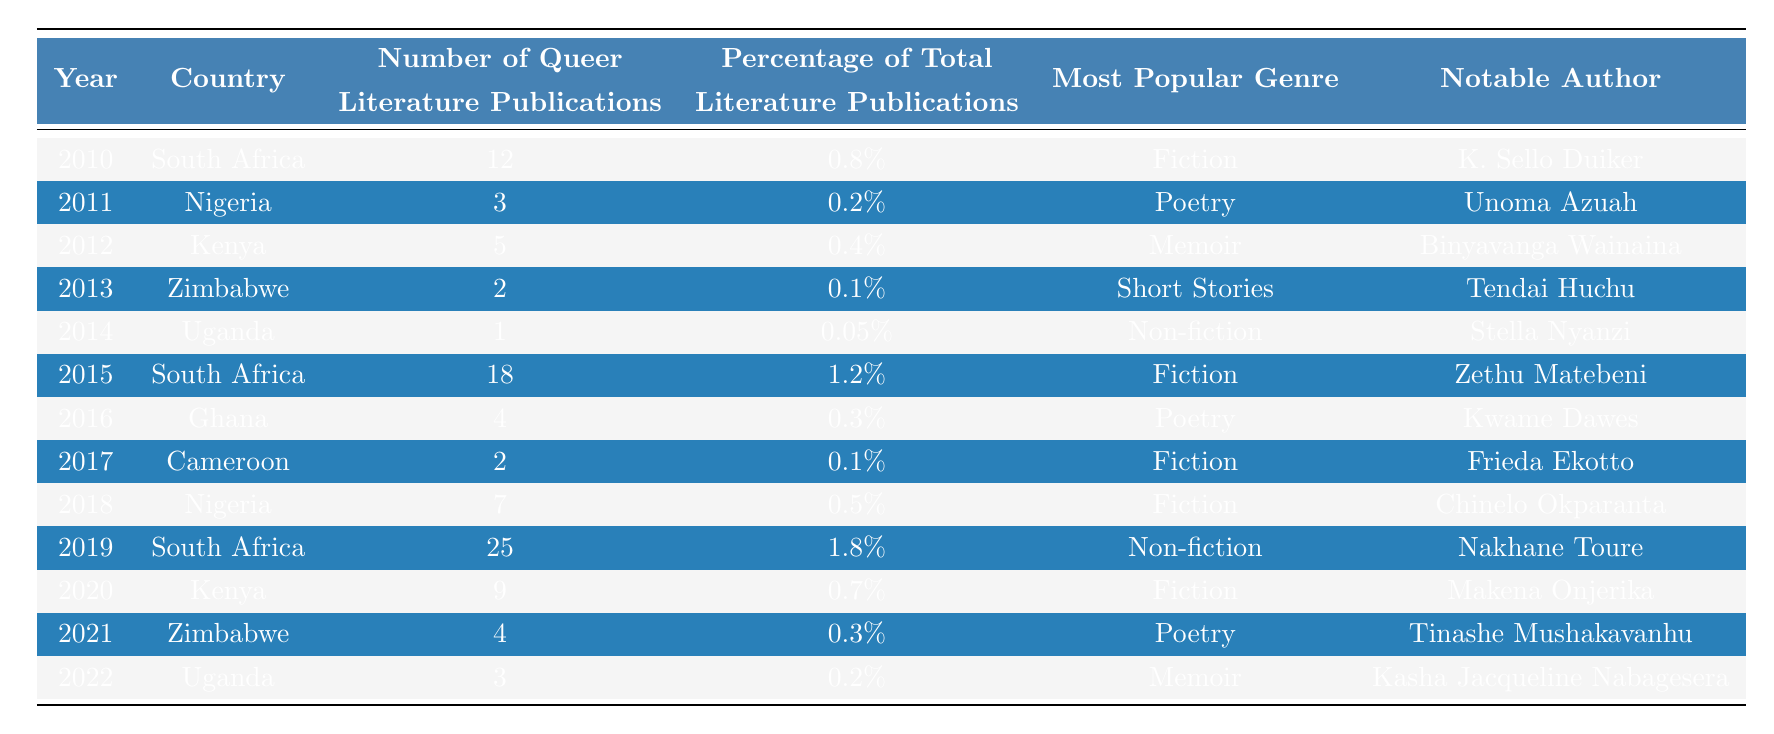What year had the highest number of queer literature publications in South Africa? In the table, the highest number of queer literature publications in South Africa is 25, which occurred in 2019.
Answer: 2019 Which country had the least number of queer literature publications, and how many were there? Looking at the table, Uganda in 2014 had only 1 publication, which is the least among all the countries listed.
Answer: Uganda, 1 What percentage of total literature publications did queer literature represent in Zimbabwe in 2021? According to the table, in 2021, queer literature publications in Zimbabwe represented 0.3% of total literature publications.
Answer: 0.3% Which genre was most popular in Nigeria and in which years did it appear? The most popular genre in Nigeria is Fiction, which appeared in 2018 (7 publications) and was the dominant genre in 2011 for poetry but with fewer publications.
Answer: Fiction, 2018 What is the total number of queer literature publications for South Africa from 2010 to 2019? Summing the queer literature publications for South Africa from 2010 (12), 2015 (18), and 2019 (25) gives a total of 55 publications (12 + 18 + 25 = 55).
Answer: 55 Is it true that Uganda had queer literature publications every year from 2010 to 2022? Analyzing the table, it shows that Uganda had publications only in 2014 (1 publication) and 2022 (3 publications), indicating they did not publish every year.
Answer: No In which country was poetry the most popular genre, and what was the number of publications in that year? The table indicates that Ghana had poetry as the most popular genre in 2016, with 4 queer literature publications that year.
Answer: Ghana, 4 Which country had the highest percentage of total literature publications for queer literature in 2019? In 2019, South Africa had the highest percentage of total literature publications for queer literature at 1.8%.
Answer: South Africa, 1.8% How many years did Kenya have queer literature publications amounting to 9 or more? By reviewing the data, Kenya had queer literature publications of 9 in 2020 and 5 in 2012, which means they only reached 9 in one year, in 2020.
Answer: 1 year Identify the notable author for queer literature in Zambia. The table does not provide any data on Zambia, making it impossible to identify a notable author from that country for queer literature.
Answer: None (Zambia not included) What trends can be observed in the number of queer literature publications across African countries from 2010 to 2022? Evaluating the data shows a general increase in queer literature publications, especially in South Africa, peaking in 2019. Most African countries have low publication numbers, highlighting a disparity in representation.
Answer: Increasing trend, disparity in representation 